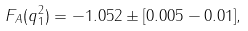<formula> <loc_0><loc_0><loc_500><loc_500>F _ { A } ( q ^ { 2 } _ { 1 } ) = - 1 . 0 5 2 \pm [ 0 . 0 0 5 - 0 . 0 1 ] ,</formula> 